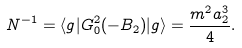Convert formula to latex. <formula><loc_0><loc_0><loc_500><loc_500>N ^ { - 1 } = \langle g | G _ { 0 } ^ { 2 } ( - B _ { 2 } ) | g \rangle = \frac { m ^ { 2 } a _ { 2 } ^ { 3 } } { 4 } .</formula> 